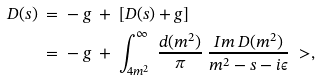<formula> <loc_0><loc_0><loc_500><loc_500>D ( s ) & \ = \ - \ g \ + \ [ D ( s ) + g ] \\ & \ = \ - \ g \ + \ \int _ { 4 m ^ { 2 } } ^ { \infty } \ \frac { d ( m ^ { 2 } ) } { \pi } \ \frac { I m \, D ( m ^ { 2 } ) } { m ^ { 2 } - s - i \epsilon } \ > ,</formula> 